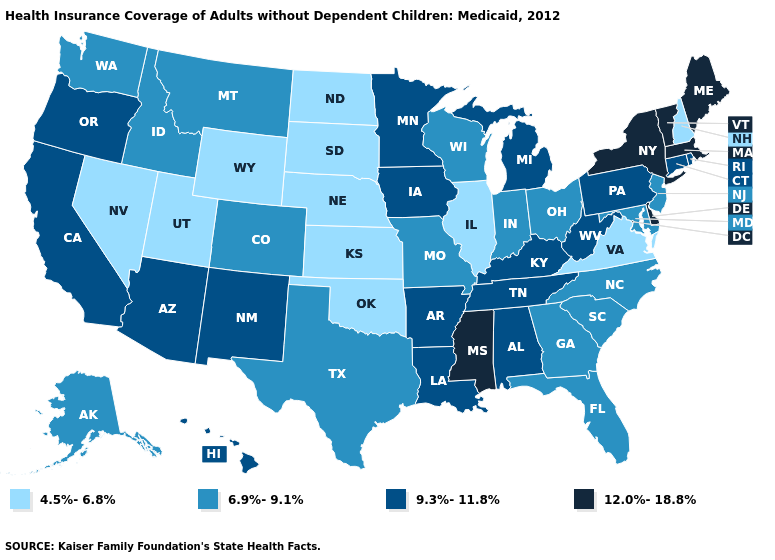Does Arkansas have the same value as Michigan?
Answer briefly. Yes. Name the states that have a value in the range 4.5%-6.8%?
Answer briefly. Illinois, Kansas, Nebraska, Nevada, New Hampshire, North Dakota, Oklahoma, South Dakota, Utah, Virginia, Wyoming. Does Vermont have the highest value in the Northeast?
Concise answer only. Yes. Does New Hampshire have the lowest value in the Northeast?
Write a very short answer. Yes. What is the lowest value in the USA?
Short answer required. 4.5%-6.8%. Name the states that have a value in the range 9.3%-11.8%?
Quick response, please. Alabama, Arizona, Arkansas, California, Connecticut, Hawaii, Iowa, Kentucky, Louisiana, Michigan, Minnesota, New Mexico, Oregon, Pennsylvania, Rhode Island, Tennessee, West Virginia. Does New Hampshire have the lowest value in the Northeast?
Give a very brief answer. Yes. What is the value of Massachusetts?
Concise answer only. 12.0%-18.8%. What is the value of Georgia?
Quick response, please. 6.9%-9.1%. How many symbols are there in the legend?
Short answer required. 4. Among the states that border Connecticut , which have the highest value?
Write a very short answer. Massachusetts, New York. Among the states that border Wyoming , does Idaho have the lowest value?
Give a very brief answer. No. Name the states that have a value in the range 12.0%-18.8%?
Concise answer only. Delaware, Maine, Massachusetts, Mississippi, New York, Vermont. What is the value of Vermont?
Keep it brief. 12.0%-18.8%. Which states have the lowest value in the Northeast?
Concise answer only. New Hampshire. 